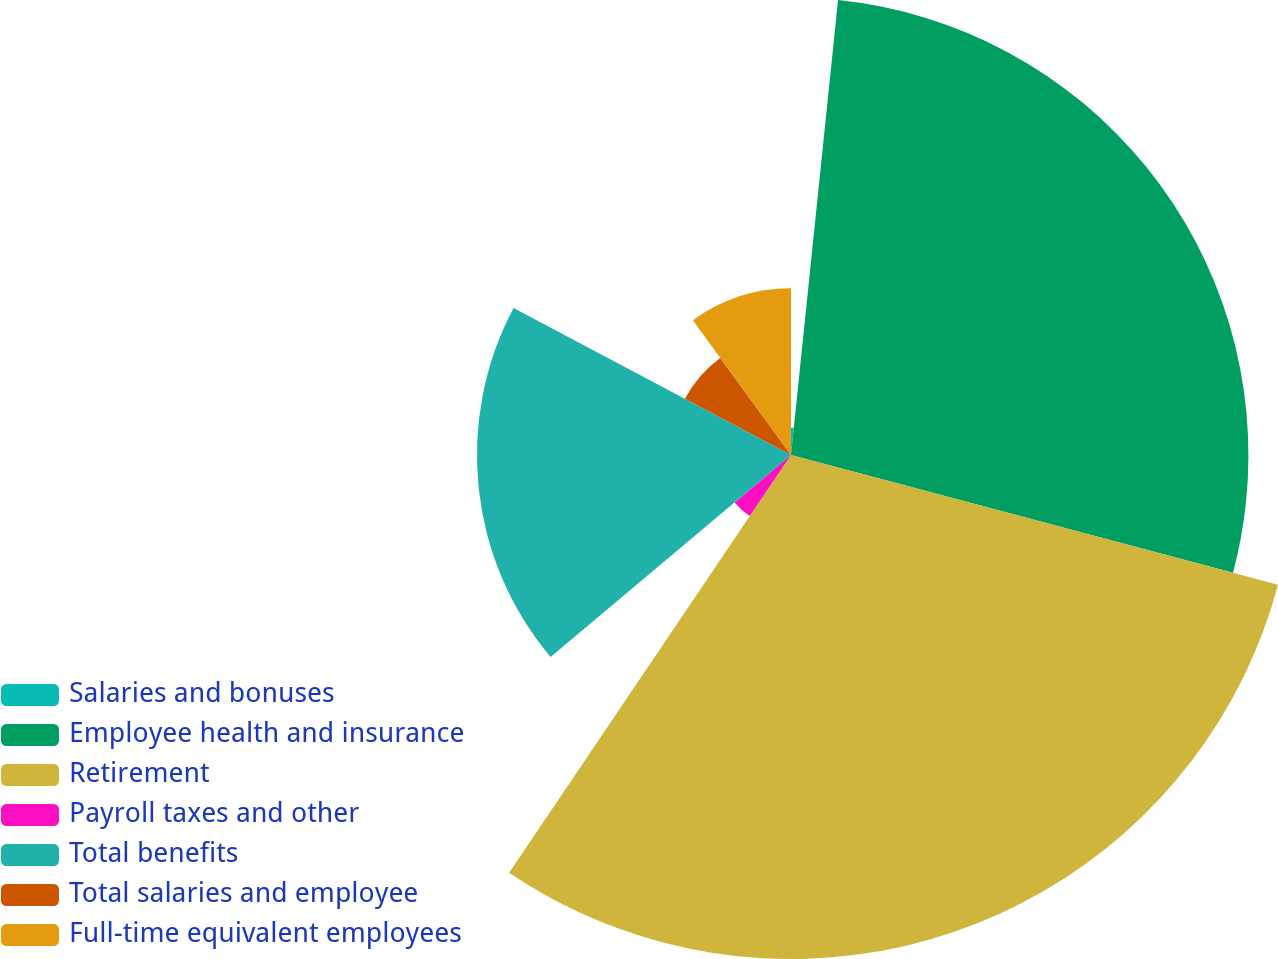Convert chart. <chart><loc_0><loc_0><loc_500><loc_500><pie_chart><fcel>Salaries and bonuses<fcel>Employee health and insurance<fcel>Retirement<fcel>Payroll taxes and other<fcel>Total benefits<fcel>Total salaries and employee<fcel>Full-time equivalent employees<nl><fcel>1.64%<fcel>27.5%<fcel>30.3%<fcel>4.43%<fcel>18.88%<fcel>7.22%<fcel>10.02%<nl></chart> 